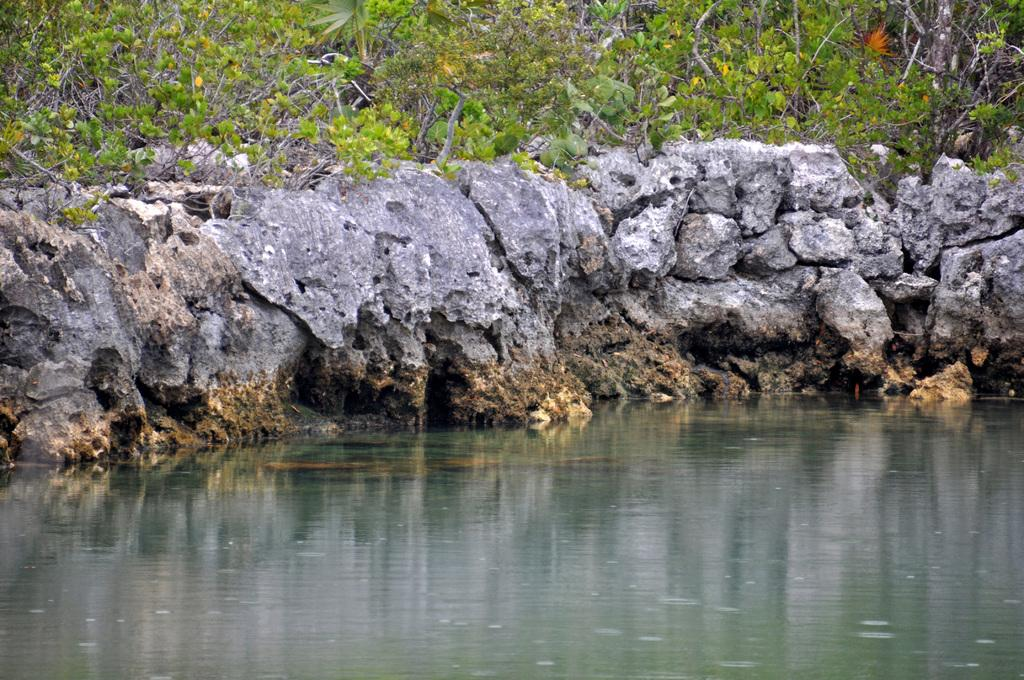What type of natural elements can be seen in the image? There are trees and rocks visible in the image. What else can be seen in the image besides trees and rocks? There is water visible in the image. How many books are stacked on the rocks in the image? There are no books present in the image; it only features trees, rocks, and water. 